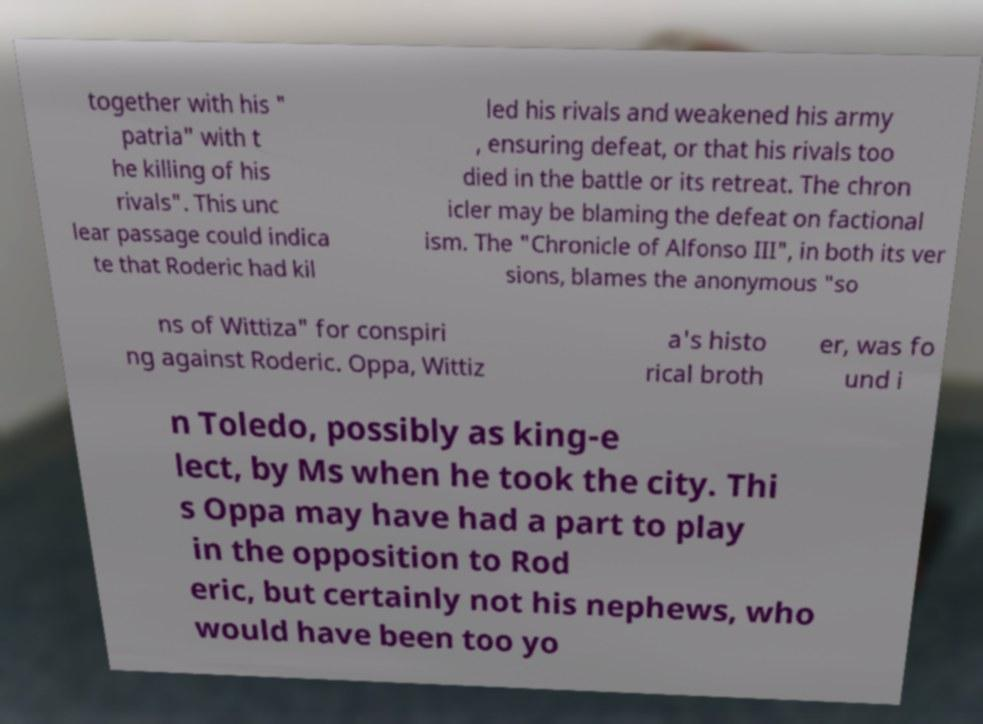Can you accurately transcribe the text from the provided image for me? together with his " patria" with t he killing of his rivals". This unc lear passage could indica te that Roderic had kil led his rivals and weakened his army , ensuring defeat, or that his rivals too died in the battle or its retreat. The chron icler may be blaming the defeat on factional ism. The "Chronicle of Alfonso III", in both its ver sions, blames the anonymous "so ns of Wittiza" for conspiri ng against Roderic. Oppa, Wittiz a's histo rical broth er, was fo und i n Toledo, possibly as king-e lect, by Ms when he took the city. Thi s Oppa may have had a part to play in the opposition to Rod eric, but certainly not his nephews, who would have been too yo 